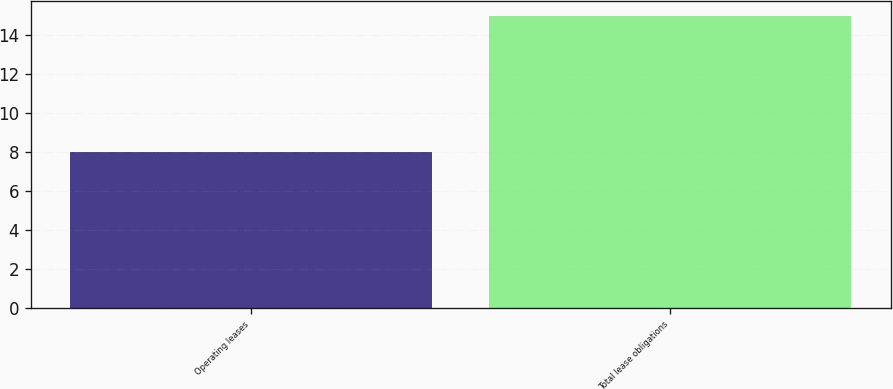Convert chart to OTSL. <chart><loc_0><loc_0><loc_500><loc_500><bar_chart><fcel>Operating leases<fcel>Total lease obligations<nl><fcel>8<fcel>15<nl></chart> 